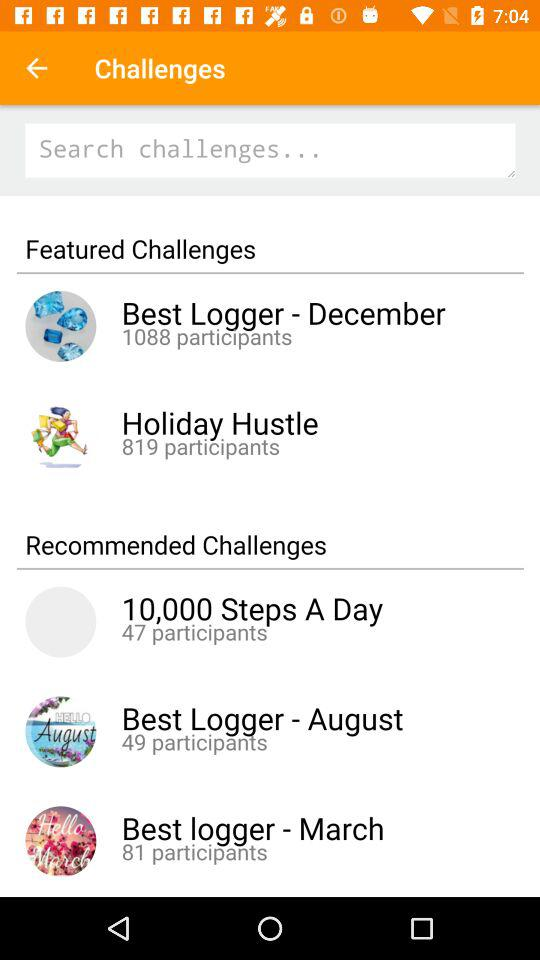To what challenge did the 49 participants belong? 49 participants belonged to the "Best Logger - August" challenge. 